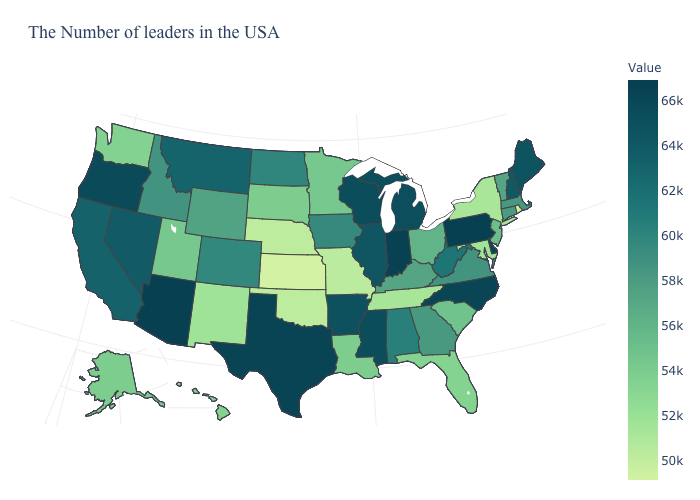Does the map have missing data?
Be succinct. No. Which states have the lowest value in the MidWest?
Quick response, please. Kansas. Does Maine have the lowest value in the Northeast?
Give a very brief answer. No. Does Indiana have the highest value in the USA?
Concise answer only. No. Is the legend a continuous bar?
Short answer required. Yes. Which states hav the highest value in the MidWest?
Give a very brief answer. Indiana. 